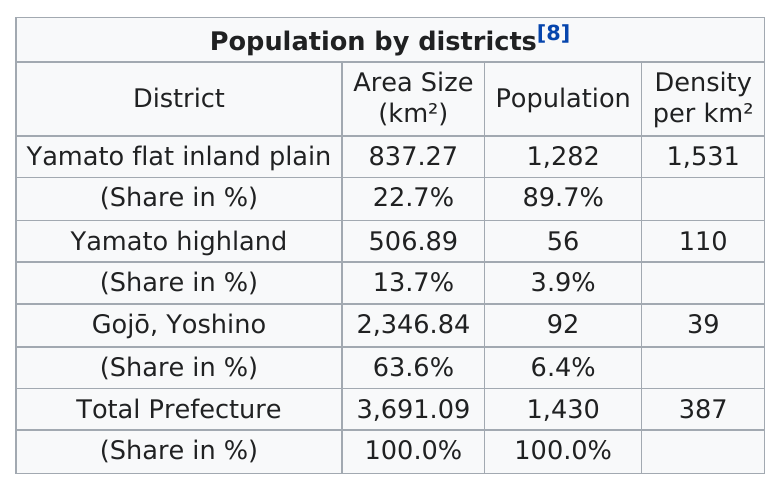Give some essential details in this illustration. The combined area size of the Yamato Flat inland plain and the Yamato highland is 1344.16 square kilometers. Yamato flat inland plain has the highest population density among all the districts. The Yamato Flat Inland Plain has a population of 1,282. Yamato Highland has the lowest percentage of total area size among all districts. The Yamato flat inland plain has the highest population among all the districts. 